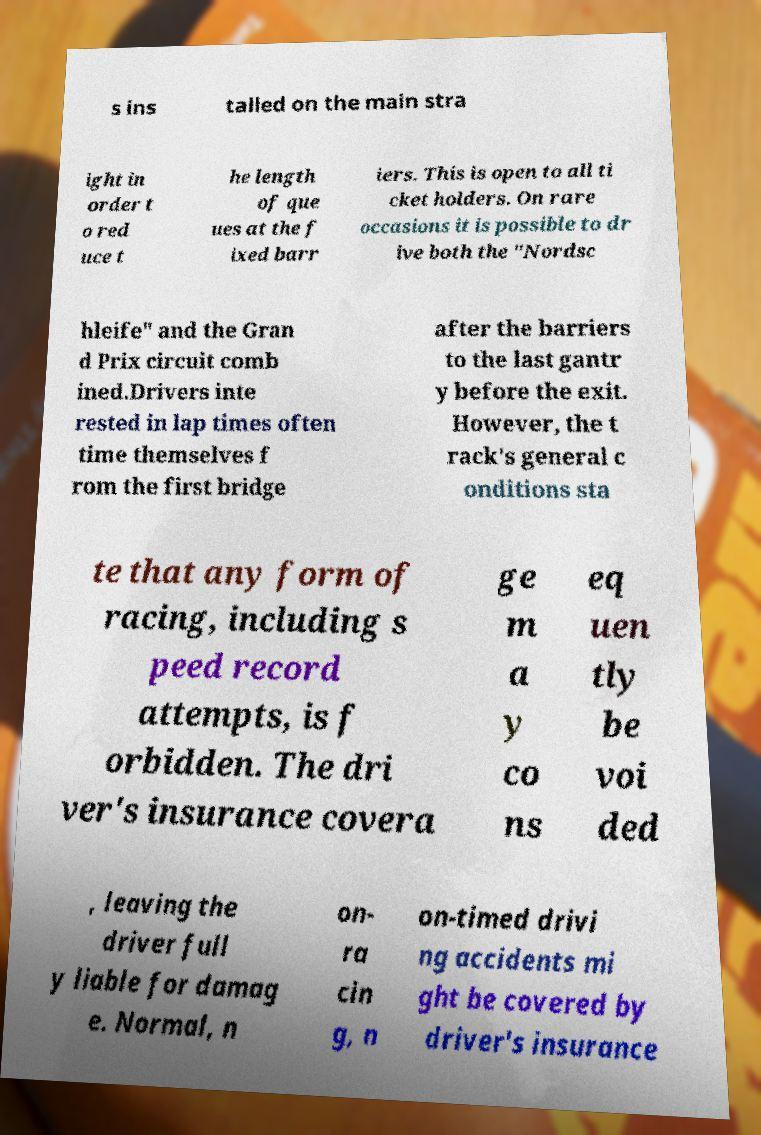For documentation purposes, I need the text within this image transcribed. Could you provide that? s ins talled on the main stra ight in order t o red uce t he length of que ues at the f ixed barr iers. This is open to all ti cket holders. On rare occasions it is possible to dr ive both the "Nordsc hleife" and the Gran d Prix circuit comb ined.Drivers inte rested in lap times often time themselves f rom the first bridge after the barriers to the last gantr y before the exit. However, the t rack's general c onditions sta te that any form of racing, including s peed record attempts, is f orbidden. The dri ver's insurance covera ge m a y co ns eq uen tly be voi ded , leaving the driver full y liable for damag e. Normal, n on- ra cin g, n on-timed drivi ng accidents mi ght be covered by driver's insurance 